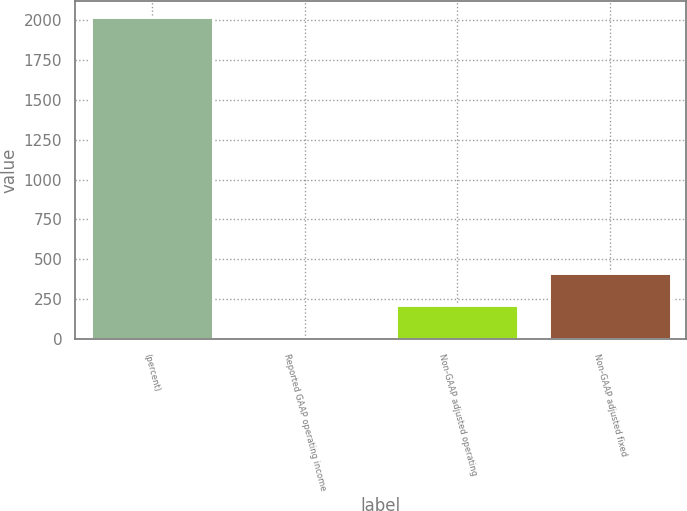Convert chart. <chart><loc_0><loc_0><loc_500><loc_500><bar_chart><fcel>(percent)<fcel>Reported GAAP operating income<fcel>Non-GAAP adjusted operating<fcel>Non-GAAP adjusted fixed<nl><fcel>2017<fcel>14.6<fcel>214.84<fcel>415.08<nl></chart> 